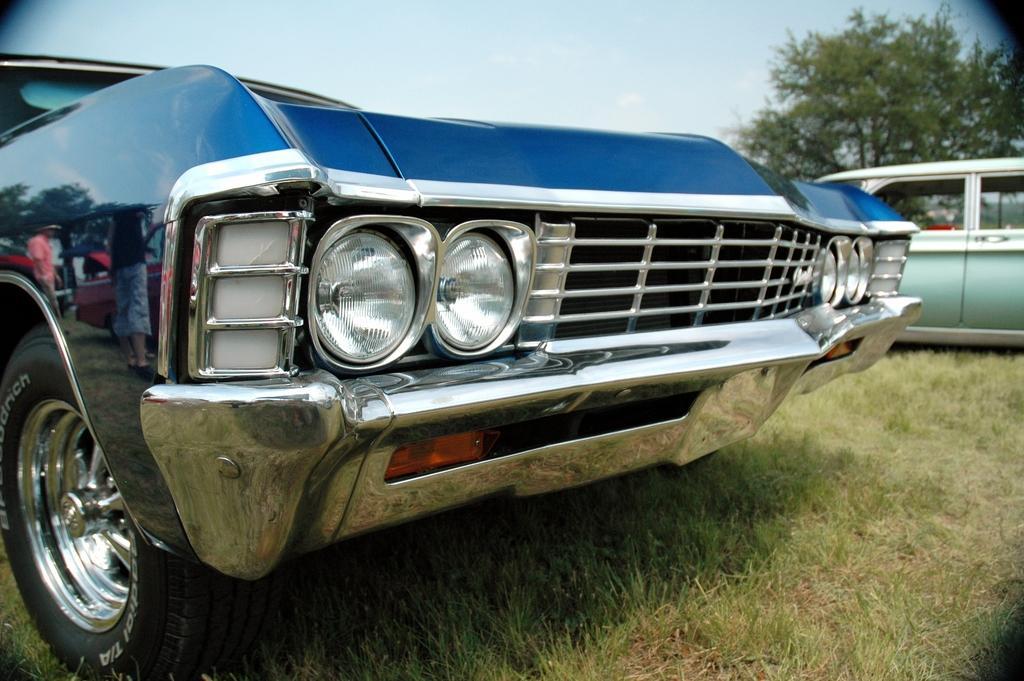Can you describe this image briefly? In this image, we can see vehicles on the ground and in the background, there are trees. 